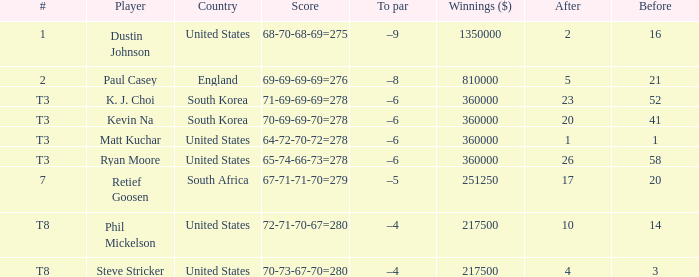What is the player listed when the score is 68-70-68-69=275 Dustin Johnson. 